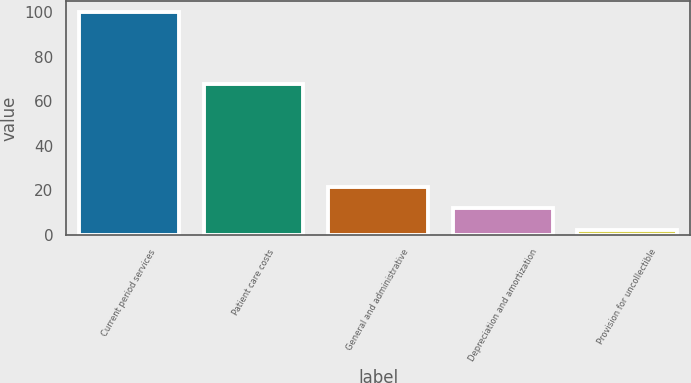<chart> <loc_0><loc_0><loc_500><loc_500><bar_chart><fcel>Current period services<fcel>Patient care costs<fcel>General and administrative<fcel>Depreciation and amortization<fcel>Provision for uncollectible<nl><fcel>100<fcel>68<fcel>21.6<fcel>11.8<fcel>2<nl></chart> 